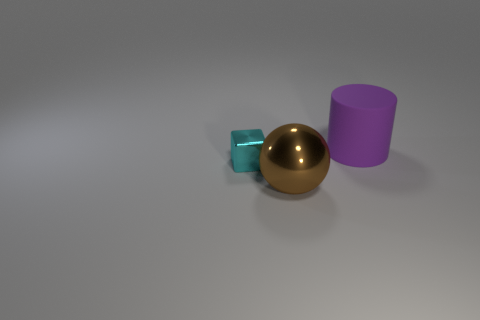What is the shape of the other matte object that is the same size as the brown thing?
Ensure brevity in your answer.  Cylinder. Is there anything else that is the same size as the cyan shiny thing?
Provide a succinct answer. No. Do the object in front of the cyan shiny thing and the purple object behind the small block have the same size?
Your answer should be compact. Yes. There is a object that is on the right side of the big brown metal thing; what is its size?
Keep it short and to the point. Large. What is the color of the metal ball that is the same size as the rubber cylinder?
Offer a terse response. Brown. Does the purple rubber object have the same size as the metallic cube?
Your answer should be very brief. No. There is a object that is both in front of the matte cylinder and on the right side of the tiny cyan metal cube; how big is it?
Keep it short and to the point. Large. How many matte objects are brown things or big red cubes?
Provide a succinct answer. 0. Is the number of large purple things in front of the block greater than the number of large red cubes?
Offer a terse response. No. There is a large thing that is on the left side of the rubber cylinder; what material is it?
Keep it short and to the point. Metal. 